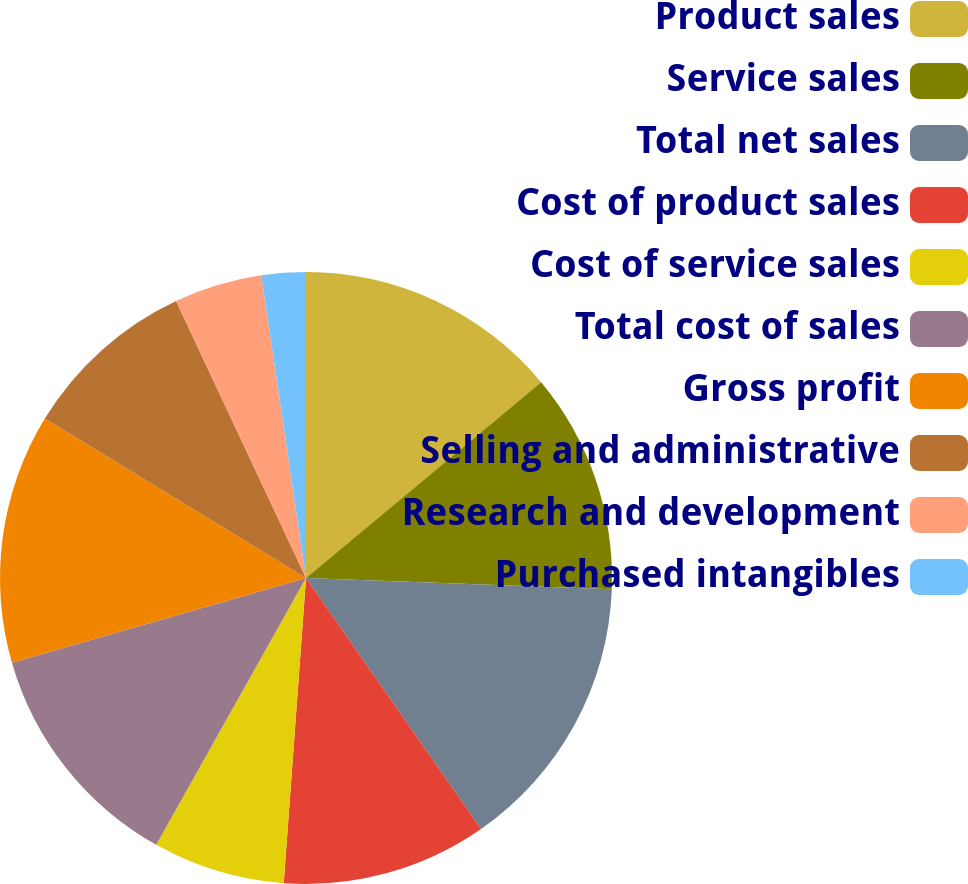Convert chart. <chart><loc_0><loc_0><loc_500><loc_500><pie_chart><fcel>Product sales<fcel>Service sales<fcel>Total net sales<fcel>Cost of product sales<fcel>Cost of service sales<fcel>Total cost of sales<fcel>Gross profit<fcel>Selling and administrative<fcel>Research and development<fcel>Purchased intangibles<nl><fcel>13.95%<fcel>11.63%<fcel>14.73%<fcel>10.85%<fcel>6.98%<fcel>12.4%<fcel>13.18%<fcel>9.3%<fcel>4.65%<fcel>2.33%<nl></chart> 